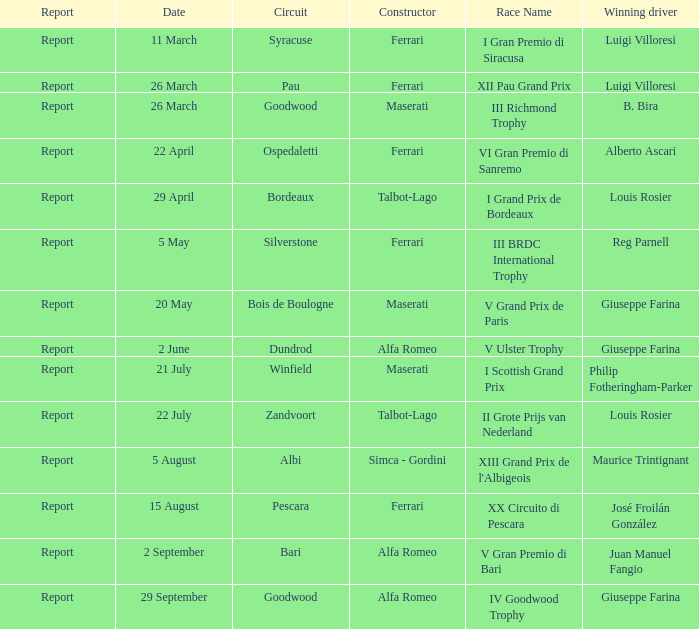Name the report on 20 may Report. 